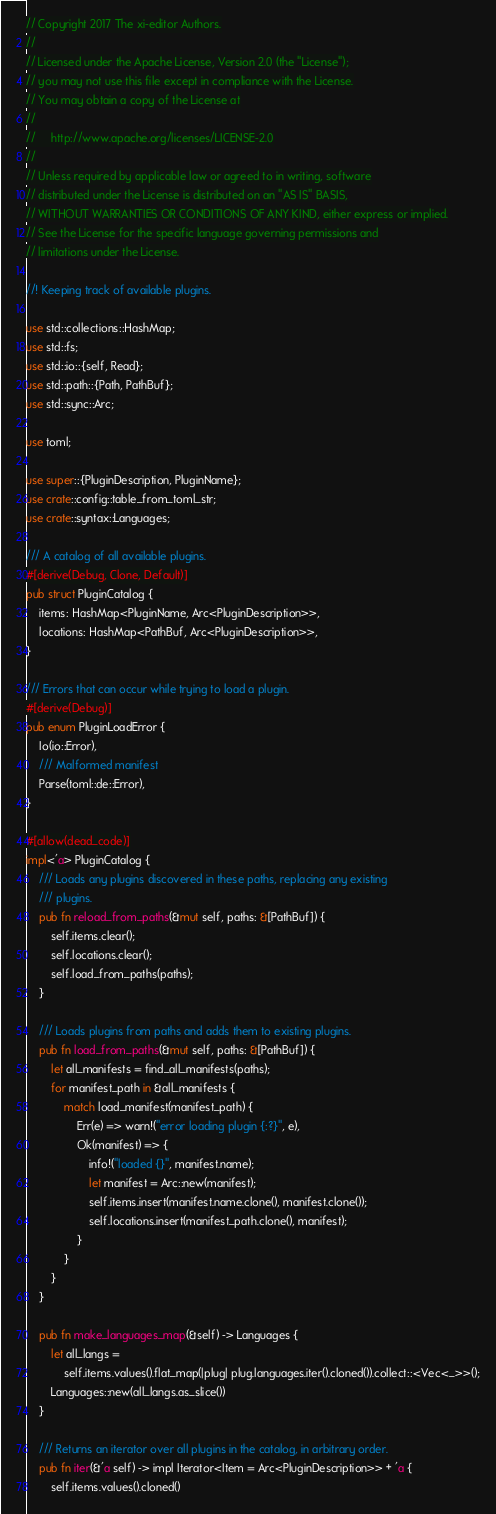Convert code to text. <code><loc_0><loc_0><loc_500><loc_500><_Rust_>// Copyright 2017 The xi-editor Authors.
//
// Licensed under the Apache License, Version 2.0 (the "License");
// you may not use this file except in compliance with the License.
// You may obtain a copy of the License at
//
//     http://www.apache.org/licenses/LICENSE-2.0
//
// Unless required by applicable law or agreed to in writing, software
// distributed under the License is distributed on an "AS IS" BASIS,
// WITHOUT WARRANTIES OR CONDITIONS OF ANY KIND, either express or implied.
// See the License for the specific language governing permissions and
// limitations under the License.

//! Keeping track of available plugins.

use std::collections::HashMap;
use std::fs;
use std::io::{self, Read};
use std::path::{Path, PathBuf};
use std::sync::Arc;

use toml;

use super::{PluginDescription, PluginName};
use crate::config::table_from_toml_str;
use crate::syntax::Languages;

/// A catalog of all available plugins.
#[derive(Debug, Clone, Default)]
pub struct PluginCatalog {
    items: HashMap<PluginName, Arc<PluginDescription>>,
    locations: HashMap<PathBuf, Arc<PluginDescription>>,
}

/// Errors that can occur while trying to load a plugin.
#[derive(Debug)]
pub enum PluginLoadError {
    Io(io::Error),
    /// Malformed manifest
    Parse(toml::de::Error),
}

#[allow(dead_code)]
impl<'a> PluginCatalog {
    /// Loads any plugins discovered in these paths, replacing any existing
    /// plugins.
    pub fn reload_from_paths(&mut self, paths: &[PathBuf]) {
        self.items.clear();
        self.locations.clear();
        self.load_from_paths(paths);
    }

    /// Loads plugins from paths and adds them to existing plugins.
    pub fn load_from_paths(&mut self, paths: &[PathBuf]) {
        let all_manifests = find_all_manifests(paths);
        for manifest_path in &all_manifests {
            match load_manifest(manifest_path) {
                Err(e) => warn!("error loading plugin {:?}", e),
                Ok(manifest) => {
                    info!("loaded {}", manifest.name);
                    let manifest = Arc::new(manifest);
                    self.items.insert(manifest.name.clone(), manifest.clone());
                    self.locations.insert(manifest_path.clone(), manifest);
                }
            }
        }
    }

    pub fn make_languages_map(&self) -> Languages {
        let all_langs =
            self.items.values().flat_map(|plug| plug.languages.iter().cloned()).collect::<Vec<_>>();
        Languages::new(all_langs.as_slice())
    }

    /// Returns an iterator over all plugins in the catalog, in arbitrary order.
    pub fn iter(&'a self) -> impl Iterator<Item = Arc<PluginDescription>> + 'a {
        self.items.values().cloned()</code> 